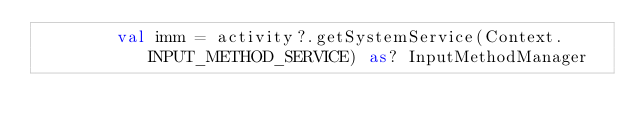Convert code to text. <code><loc_0><loc_0><loc_500><loc_500><_Kotlin_>        val imm = activity?.getSystemService(Context.INPUT_METHOD_SERVICE) as? InputMethodManager</code> 